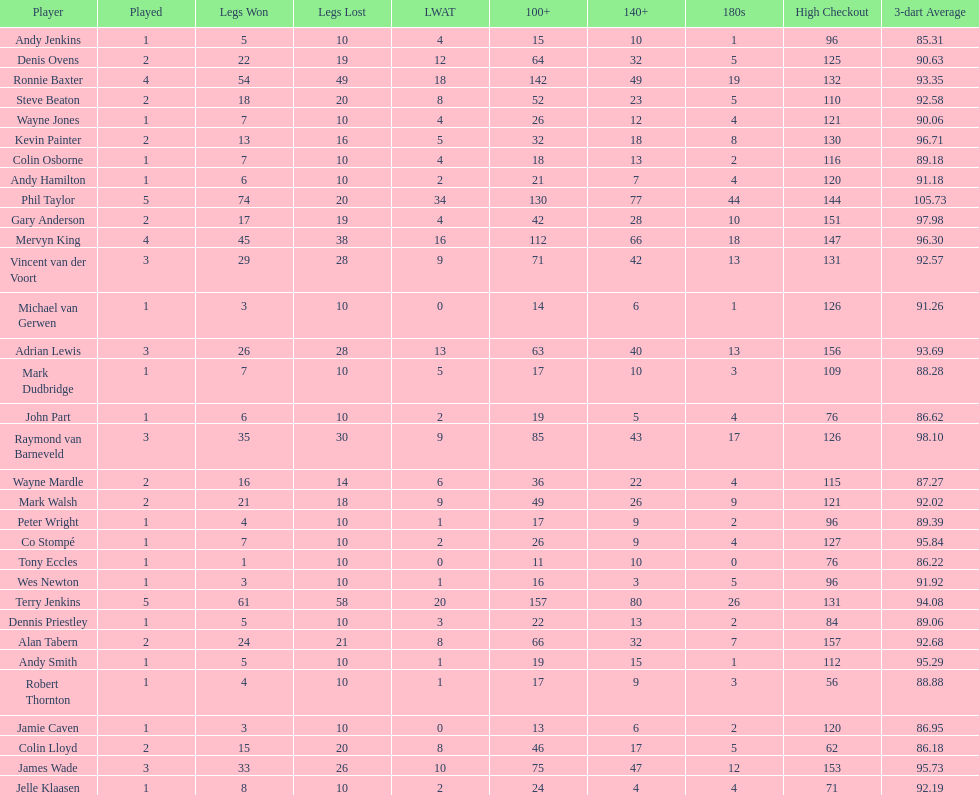Which player lost the least? Co Stompé, Andy Smith, Jelle Klaasen, Wes Newton, Michael van Gerwen, Andy Hamilton, Wayne Jones, Peter Wright, Colin Osborne, Dennis Priestley, Robert Thornton, Mark Dudbridge, Jamie Caven, John Part, Tony Eccles, Andy Jenkins. 